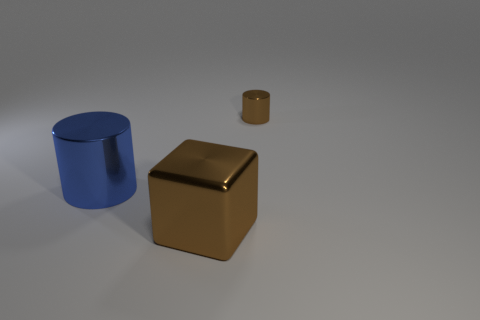Is the shape of the blue thing the same as the tiny object?
Your answer should be compact. Yes. What is the material of the thing that is both behind the large brown object and in front of the small cylinder?
Ensure brevity in your answer.  Metal. How many other blue things are the same shape as the blue thing?
Your answer should be compact. 0. How big is the thing left of the brown metal object left of the brown metal thing behind the large brown cube?
Your answer should be very brief. Large. Are there more big shiny things in front of the large blue shiny cylinder than large gray matte objects?
Provide a succinct answer. Yes. Are there any big brown cubes?
Ensure brevity in your answer.  Yes. What number of purple rubber things are the same size as the blue object?
Your answer should be compact. 0. Is the number of large metal objects behind the large brown cube greater than the number of large brown things behind the tiny cylinder?
Provide a short and direct response. Yes. There is a blue cylinder that is the same size as the brown metal block; what is its material?
Provide a succinct answer. Metal. What is the shape of the small brown metallic object?
Your response must be concise. Cylinder. 